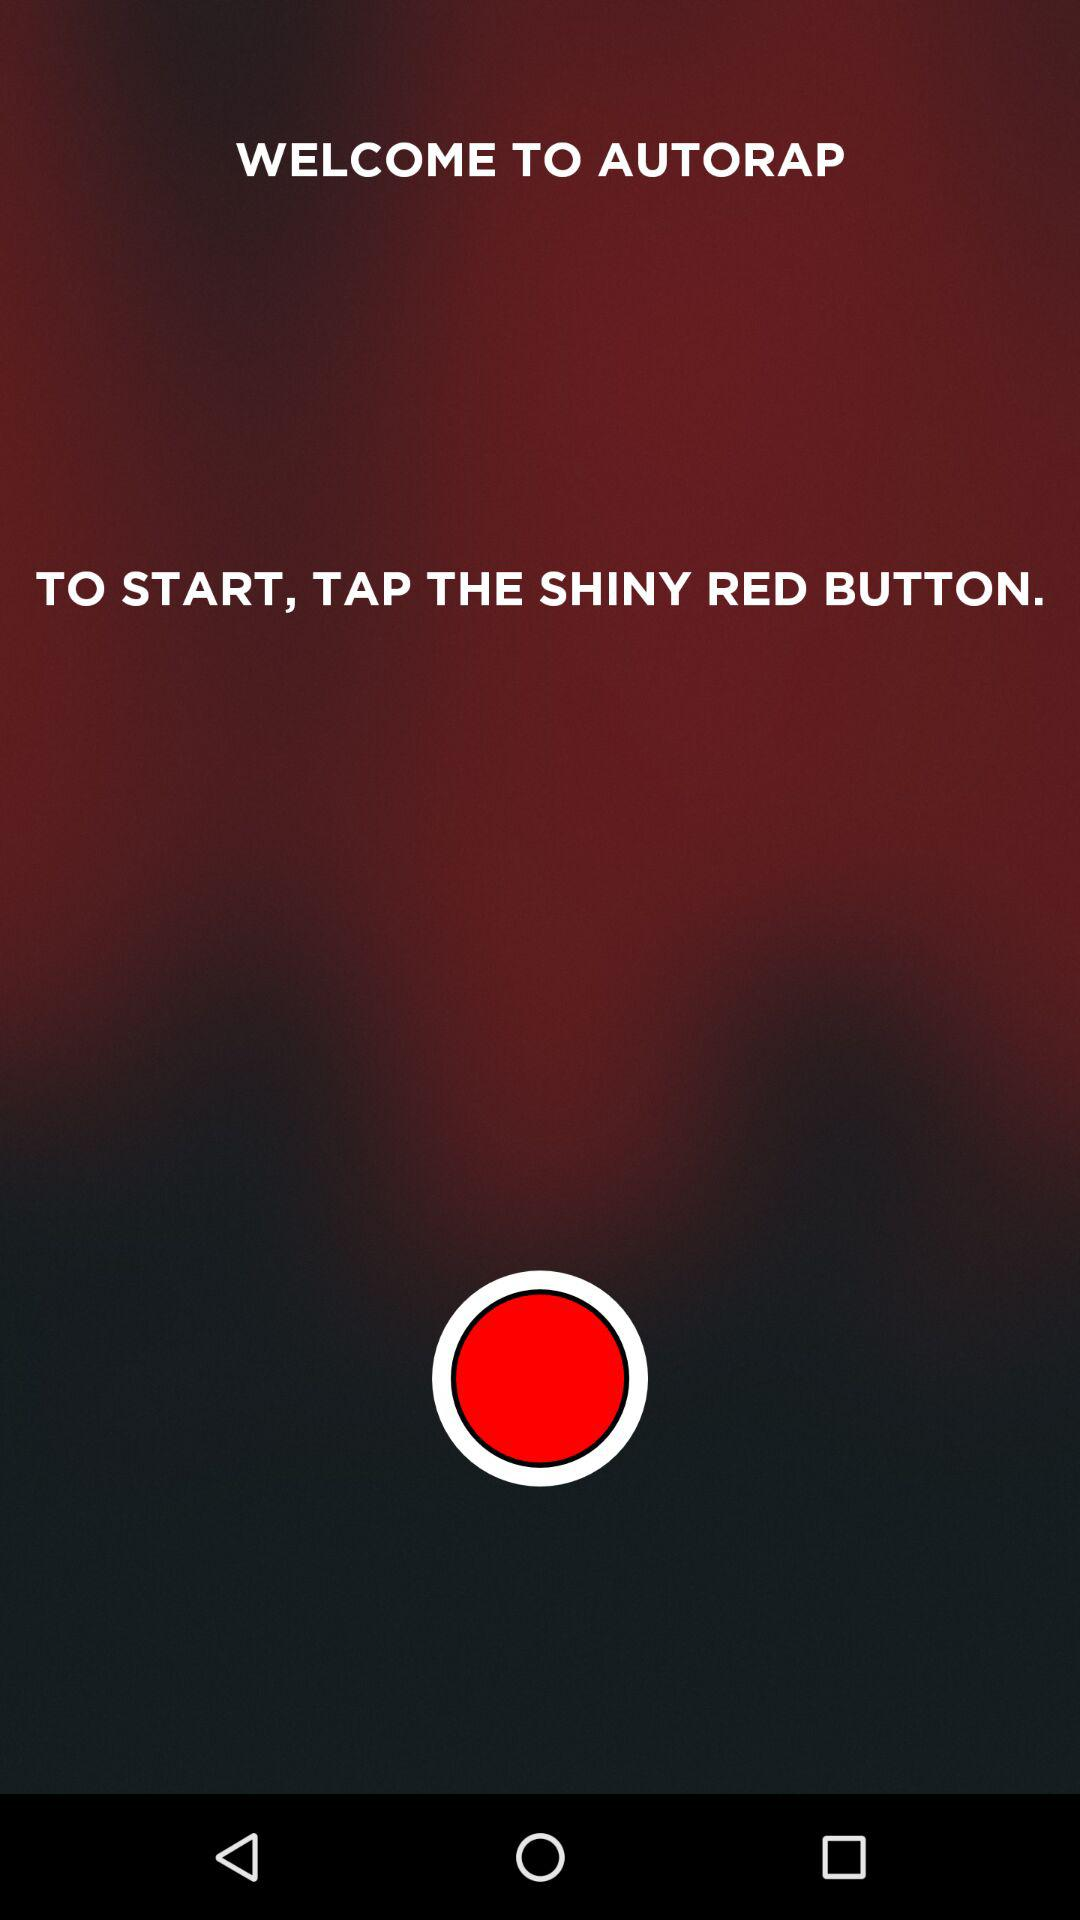What is the name of the application? The name of the application is "AUTORAP". 